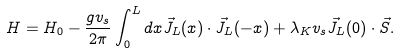<formula> <loc_0><loc_0><loc_500><loc_500>H = H _ { 0 } - \frac { g v _ { s } } { 2 \pi } \int _ { 0 } ^ { L } d x \vec { J } _ { L } ( x ) \cdot \vec { J } _ { L } ( - x ) + \lambda _ { K } v _ { s } \vec { J } _ { L } ( 0 ) \cdot \vec { S } .</formula> 